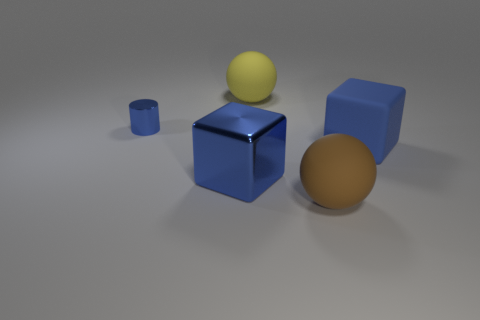What number of things are either small shiny objects or large matte things on the right side of the large yellow ball?
Make the answer very short. 3. There is a blue object that is the same size as the shiny block; what is its shape?
Your answer should be very brief. Cube. What number of metal cubes are the same color as the small cylinder?
Give a very brief answer. 1. Are the blue cube to the left of the big brown matte thing and the blue cylinder made of the same material?
Provide a short and direct response. Yes. There is a tiny metallic object; what shape is it?
Provide a short and direct response. Cylinder. How many red things are either metal objects or large matte things?
Make the answer very short. 0. How many other things are there of the same material as the yellow object?
Offer a very short reply. 2. There is a rubber object that is to the left of the brown sphere; is it the same shape as the brown thing?
Offer a very short reply. Yes. Are there any large blue metal things?
Provide a succinct answer. Yes. Is there any other thing that is the same shape as the tiny object?
Keep it short and to the point. No. 